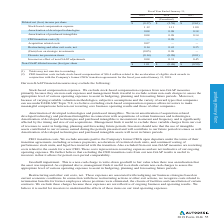Looking at Autodesk's financial data, please calculate: What was the difference in net cash provided by operating activities in 2019? Based on the calculation: 377.1-0.9 , the result is 376.2. The key data points involved are: 0.9, 377.1. Also, What does Autodesk use cash for? Based on the financial document, the answer is Our primary use of cash is payment of our operating costs, which consist primarily of employee-related expenses, such as compensation and benefits, as well as general operating expenses for marketing, facilities and overhead costs. In addition to operating expenses, we also use cash to fund our stock repurchase program and invest in our growth initiatives, which include acquisitions of products, technology and businesses.. Also, What was the net cash used in investing activities in 2019 used for? Based on the financial document, the answer is Net cash used in investing activities was $710.4 million for fiscal 2019 and was primarily due to acquisitions, net of cash acquired and purchases of marketable securities. These cash outflows were partially offset by sales and maturities of marketable securities. Also, can you calculate: How much is the increase in primary working capital use of cash from 2018 to 2019? Based on the calculation: 2,091.4-1,955.1, the result is 136.3 (in millions). The key data points involved are: 1,955.1, 2,091.4. Also, How much of company's cash equivalents and marketable securities are located in foreign jurisdictions as of 31 Jan 2019? Based on the financial document, the answer is 52%. Also, can you calculate: How much did the net cash provided by operating activities gain from fiscal year ending 31 January, 2019 compared to that of fiscal year ending 31 January, 2017? To answer this question, I need to perform calculations using the financial data. The calculation is: (377.1-169.7)/169.7 , which equals 122.22 (percentage). The key data points involved are: 169.7, 377.1. 